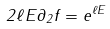<formula> <loc_0><loc_0><loc_500><loc_500>2 \ell E \partial _ { 2 } f = e ^ { \ell E }</formula> 